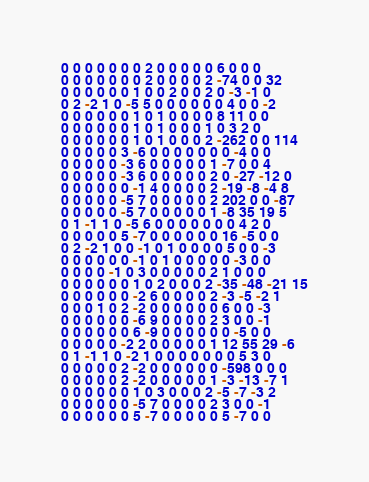<code> <loc_0><loc_0><loc_500><loc_500><_SQL_>0 0 0 0 0 0 0 2 0 0 0 0 0 6 0 0 0
0 0 0 0 0 0 0 2 0 0 0 0 2 -74 0 0 32
0 0 0 0 0 0 1 0 0 2 0 0 2 0 -3 -1 0
0 2 -2 1 0 -5 5 0 0 0 0 0 0 4 0 0 -2
0 0 0 0 0 0 1 0 1 0 0 0 0 8 11 0 0
0 0 0 0 0 0 1 0 1 0 0 0 1 0 3 2 0
0 0 0 0 0 0 1 0 1 0 0 0 2 -262 0 0 114
0 0 0 0 0 3 -6 0 0 0 0 0 0 0 -4 0 0
0 0 0 0 0 -3 6 0 0 0 0 0 1 -7 0 0 4
0 0 0 0 0 -3 6 0 0 0 0 0 2 0 -27 -12 0
0 0 0 0 0 0 -1 4 0 0 0 0 2 -19 -8 -4 8
0 0 0 0 0 -5 7 0 0 0 0 0 2 202 0 0 -87
0 0 0 0 0 -5 7 0 0 0 0 0 1 -8 35 19 5
0 1 -1 1 0 -5 6 0 0 0 0 0 0 0 4 2 0
0 0 0 0 0 5 -7 0 0 0 0 0 0 16 -5 0 0
0 2 -2 1 0 0 -1 0 1 0 0 0 0 5 0 0 -3
0 0 0 0 0 0 -1 0 1 0 0 0 0 0 -3 0 0
0 0 0 0 -1 0 3 0 0 0 0 0 2 1 0 0 0
0 0 0 0 0 0 1 0 2 0 0 0 2 -35 -48 -21 15
0 0 0 0 0 0 -2 6 0 0 0 0 2 -3 -5 -2 1
0 0 0 1 0 2 -2 0 0 0 0 0 0 6 0 0 -3
0 0 0 0 0 0 -6 9 0 0 0 0 2 3 0 0 -1
0 0 0 0 0 0 6 -9 0 0 0 0 0 0 -5 0 0
0 0 0 0 0 -2 2 0 0 0 0 0 1 12 55 29 -6
0 1 -1 1 0 -2 1 0 0 0 0 0 0 0 5 3 0
0 0 0 0 0 2 -2 0 0 0 0 0 0 -598 0 0 0
0 0 0 0 0 2 -2 0 0 0 0 0 1 -3 -13 -7 1
0 0 0 0 0 0 1 0 3 0 0 0 2 -5 -7 -3 2
0 0 0 0 0 0 -5 7 0 0 0 0 2 3 0 0 -1
0 0 0 0 0 0 5 -7 0 0 0 0 0 5 -7 0 0</code> 